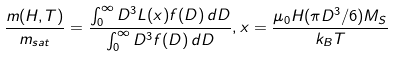Convert formula to latex. <formula><loc_0><loc_0><loc_500><loc_500>\frac { m ( H , T ) } { m _ { s a t } } = \frac { \int _ { 0 } ^ { \infty } D ^ { 3 } L ( x ) f ( D ) \, d D } { \int _ { 0 } ^ { \infty } D ^ { 3 } f ( D ) \, d D } , x = \frac { \mu _ { 0 } H ( \pi D ^ { 3 } / 6 ) M _ { S } } { k _ { B } T }</formula> 